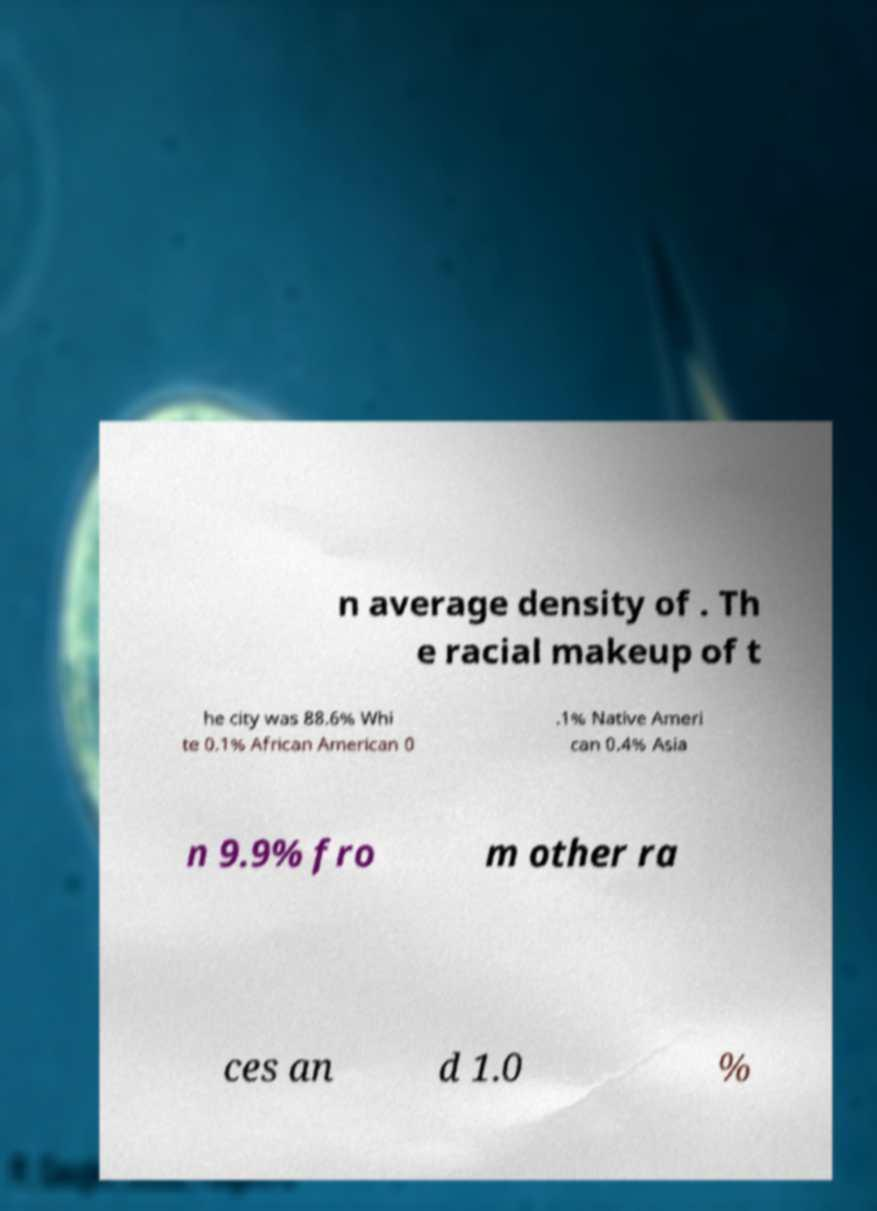I need the written content from this picture converted into text. Can you do that? n average density of . Th e racial makeup of t he city was 88.6% Whi te 0.1% African American 0 .1% Native Ameri can 0.4% Asia n 9.9% fro m other ra ces an d 1.0 % 